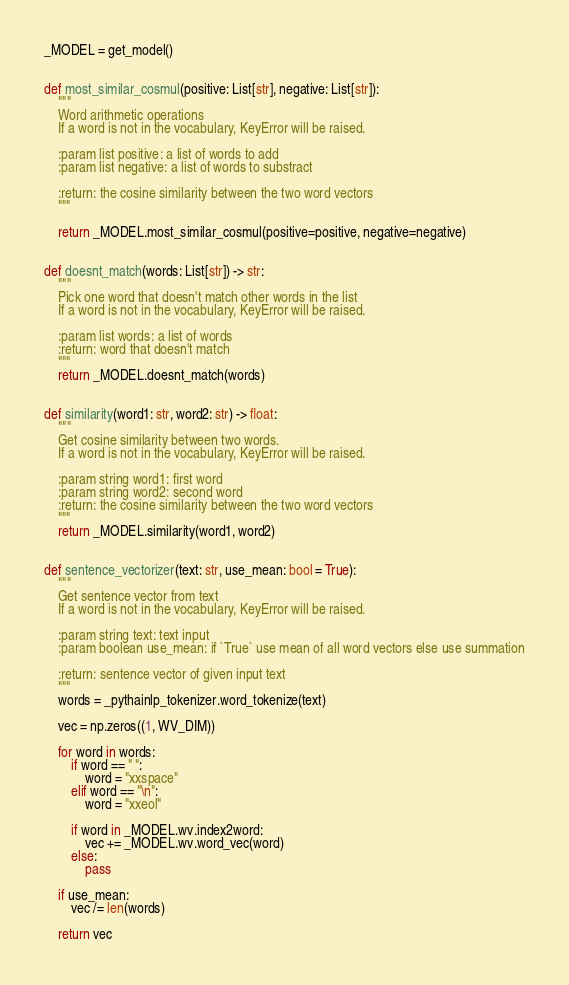Convert code to text. <code><loc_0><loc_0><loc_500><loc_500><_Python_>_MODEL = get_model()


def most_similar_cosmul(positive: List[str], negative: List[str]):
    """
    Word arithmetic operations
    If a word is not in the vocabulary, KeyError will be raised.

    :param list positive: a list of words to add
    :param list negative: a list of words to substract

    :return: the cosine similarity between the two word vectors
    """

    return _MODEL.most_similar_cosmul(positive=positive, negative=negative)


def doesnt_match(words: List[str]) -> str:
    """
    Pick one word that doesn't match other words in the list
    If a word is not in the vocabulary, KeyError will be raised.

    :param list words: a list of words
    :return: word that doesn't match
    """
    return _MODEL.doesnt_match(words)


def similarity(word1: str, word2: str) -> float:
    """
    Get cosine similarity between two words.
    If a word is not in the vocabulary, KeyError will be raised.

    :param string word1: first word
    :param string word2: second word
    :return: the cosine similarity between the two word vectors
    """
    return _MODEL.similarity(word1, word2)


def sentence_vectorizer(text: str, use_mean: bool = True):
    """
    Get sentence vector from text
    If a word is not in the vocabulary, KeyError will be raised.

    :param string text: text input
    :param boolean use_mean: if `True` use mean of all word vectors else use summation

    :return: sentence vector of given input text
    """
    words = _pythainlp_tokenizer.word_tokenize(text)

    vec = np.zeros((1, WV_DIM))

    for word in words:
        if word == " ":
            word = "xxspace"
        elif word == "\n":
            word = "xxeol"

        if word in _MODEL.wv.index2word:
            vec += _MODEL.wv.word_vec(word)
        else:
            pass

    if use_mean:
        vec /= len(words)

    return vec
</code> 